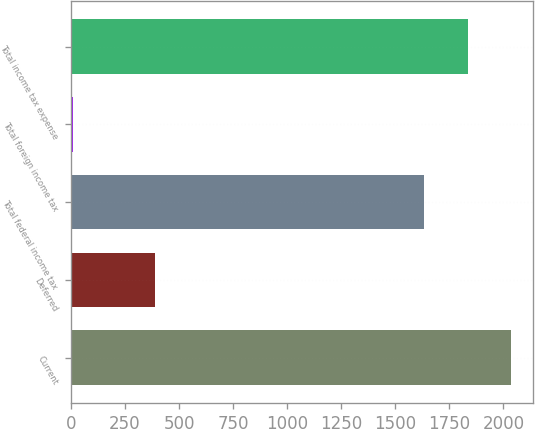Convert chart to OTSL. <chart><loc_0><loc_0><loc_500><loc_500><bar_chart><fcel>Current<fcel>Deferred<fcel>Total federal income tax<fcel>Total foreign income tax<fcel>Total income tax expense<nl><fcel>2034.8<fcel>387<fcel>1633<fcel>11<fcel>1833.9<nl></chart> 